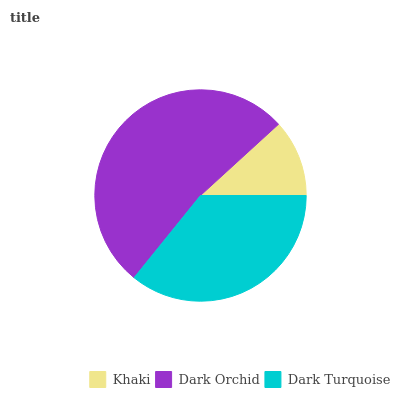Is Khaki the minimum?
Answer yes or no. Yes. Is Dark Orchid the maximum?
Answer yes or no. Yes. Is Dark Turquoise the minimum?
Answer yes or no. No. Is Dark Turquoise the maximum?
Answer yes or no. No. Is Dark Orchid greater than Dark Turquoise?
Answer yes or no. Yes. Is Dark Turquoise less than Dark Orchid?
Answer yes or no. Yes. Is Dark Turquoise greater than Dark Orchid?
Answer yes or no. No. Is Dark Orchid less than Dark Turquoise?
Answer yes or no. No. Is Dark Turquoise the high median?
Answer yes or no. Yes. Is Dark Turquoise the low median?
Answer yes or no. Yes. Is Dark Orchid the high median?
Answer yes or no. No. Is Dark Orchid the low median?
Answer yes or no. No. 